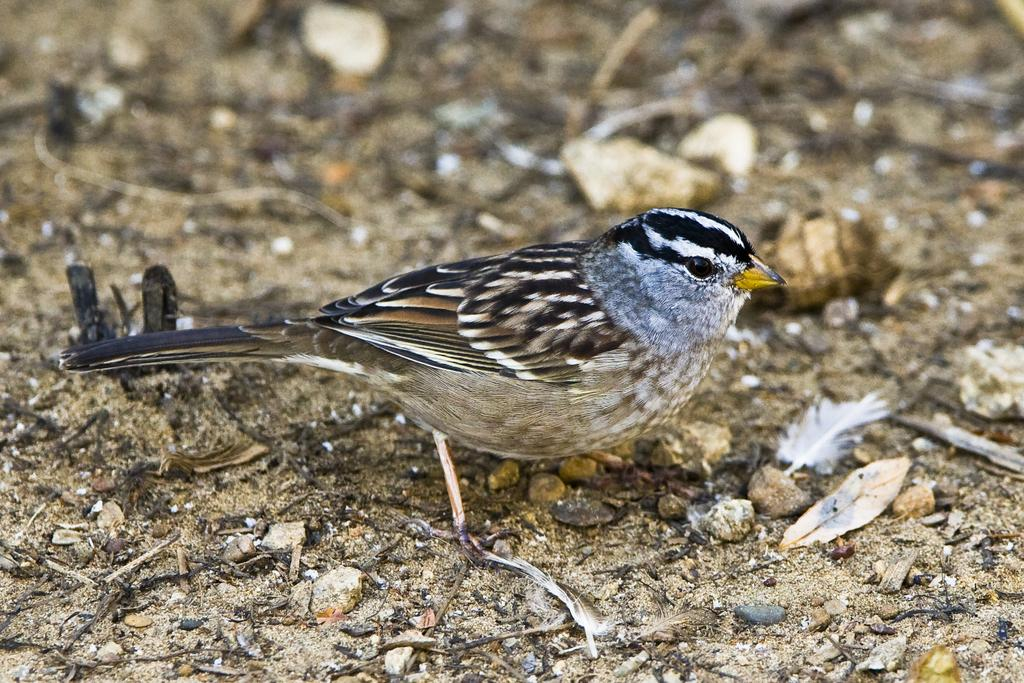What type of animal is in the image? There is a bird in the image. Can you describe the bird's fur? The bird's fur is black, brown, and white. What color is the bird's beak? The bird's beak is yellow. What time of day is the bird playing chess in the image? There is no chess game or indication of time of day in the image; it simply shows a bird with black, brown, and white fur and a yellow beak. 